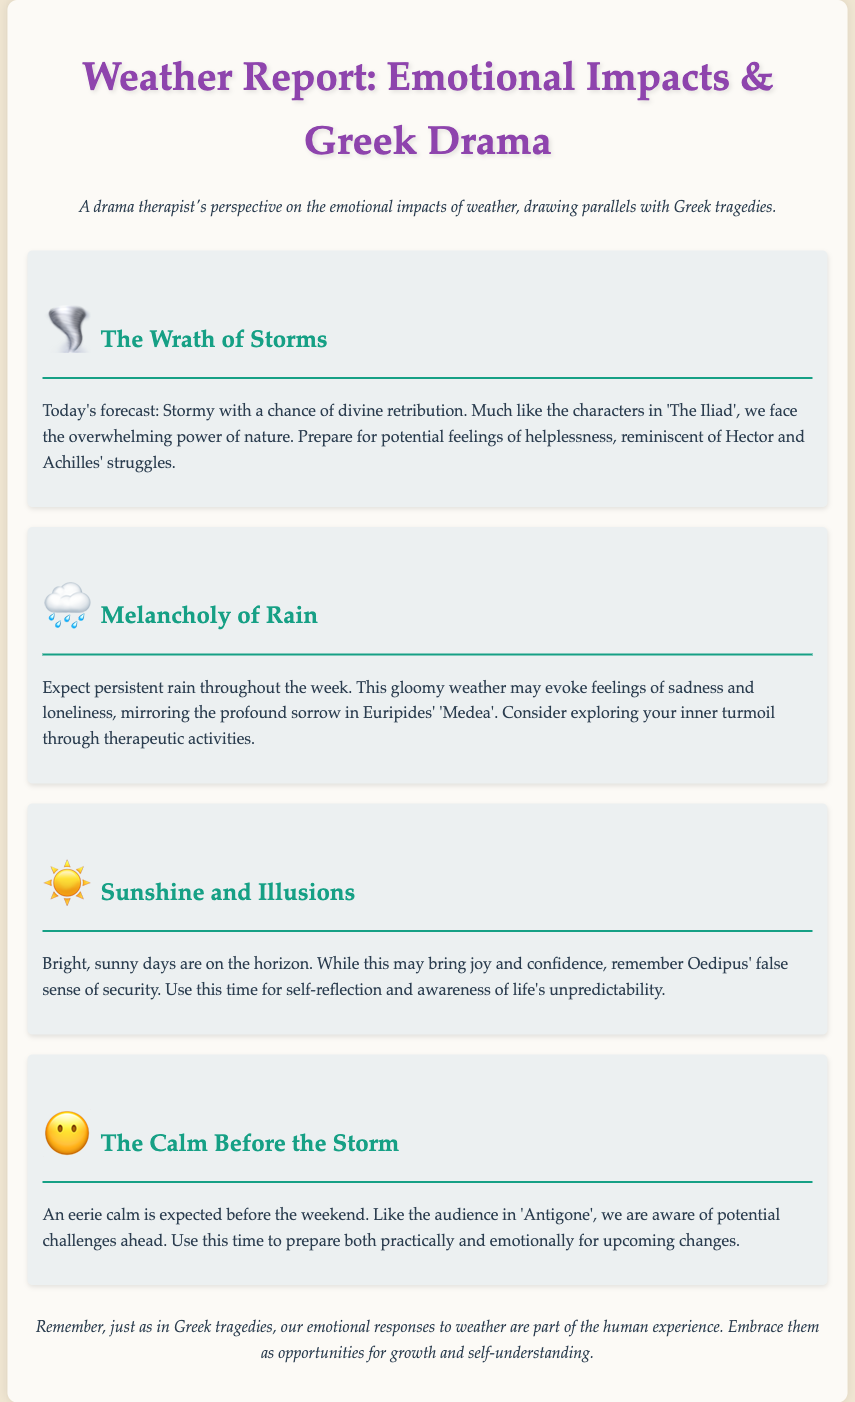What is the first weather event discussed? The first weather event discussed in the document is "The Wrath of Storms."
Answer: The Wrath of Storms What literary work is referenced concerning the stormy weather? The literary work referenced is "The Iliad."
Answer: The Iliad How does the document describe the expected rain? The document describes the expected rain as "persistent."
Answer: persistent What emotion is associated with the sunshine forecast? The emotion associated with the sunshine forecast is "joy."
Answer: joy Which tragic character's sense of security is mentioned in relation to sunny weather? The tragic character mentioned is "Oedipus."
Answer: Oedipus What should people prepare for during the calm before the storm? People should prepare for "upcoming changes."
Answer: upcoming changes What aesthetic element is used in the weather report title? The aesthetic element used is "Emotional Impacts & Greek Drama."
Answer: Emotional Impacts & Greek Drama Which Greek tragedy is referenced in relation to the calm before the storm? The Greek tragedy referenced is "Antigone."
Answer: Antigone How does the document suggest individuals cope with their emotions related to weather? The document suggests individuals explore their emotions through "therapeutic activities."
Answer: therapeutic activities 